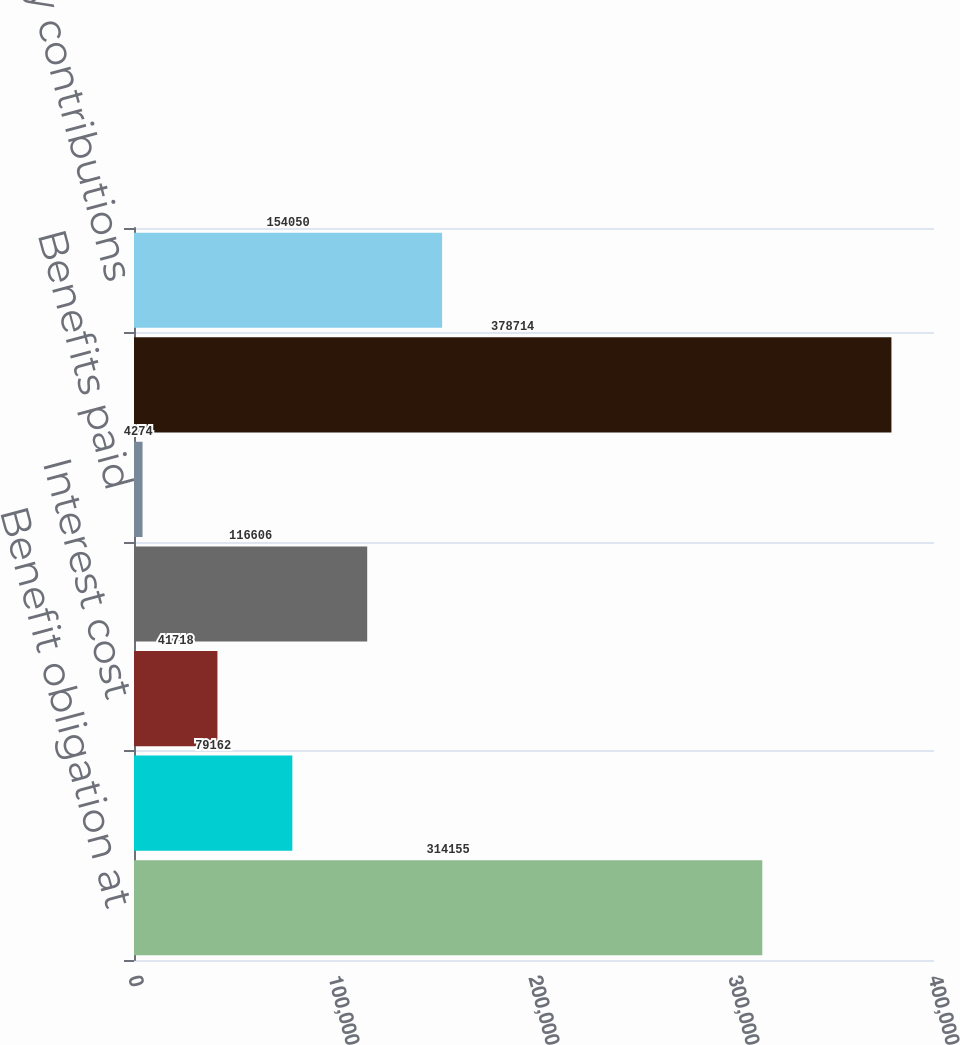<chart> <loc_0><loc_0><loc_500><loc_500><bar_chart><fcel>Benefit obligation at<fcel>Service cost<fcel>Interest cost<fcel>Actuarial loss<fcel>Benefits paid<fcel>Benefit obligation at plan<fcel>Company contributions<nl><fcel>314155<fcel>79162<fcel>41718<fcel>116606<fcel>4274<fcel>378714<fcel>154050<nl></chart> 